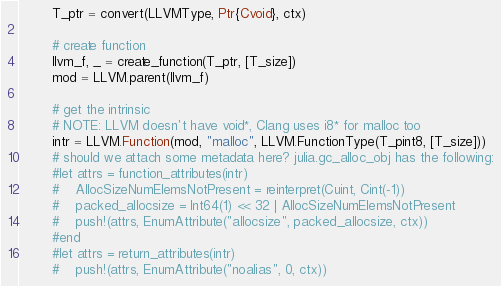<code> <loc_0><loc_0><loc_500><loc_500><_Julia_>        T_ptr = convert(LLVMType, Ptr{Cvoid}, ctx)

        # create function
        llvm_f, _ = create_function(T_ptr, [T_size])
        mod = LLVM.parent(llvm_f)

        # get the intrinsic
        # NOTE: LLVM doesn't have void*, Clang uses i8* for malloc too
        intr = LLVM.Function(mod, "malloc", LLVM.FunctionType(T_pint8, [T_size]))
        # should we attach some metadata here? julia.gc_alloc_obj has the following:
        #let attrs = function_attributes(intr)
        #    AllocSizeNumElemsNotPresent = reinterpret(Cuint, Cint(-1))
        #    packed_allocsize = Int64(1) << 32 | AllocSizeNumElemsNotPresent
        #    push!(attrs, EnumAttribute("allocsize", packed_allocsize, ctx))
        #end
        #let attrs = return_attributes(intr)
        #    push!(attrs, EnumAttribute("noalias", 0, ctx))</code> 